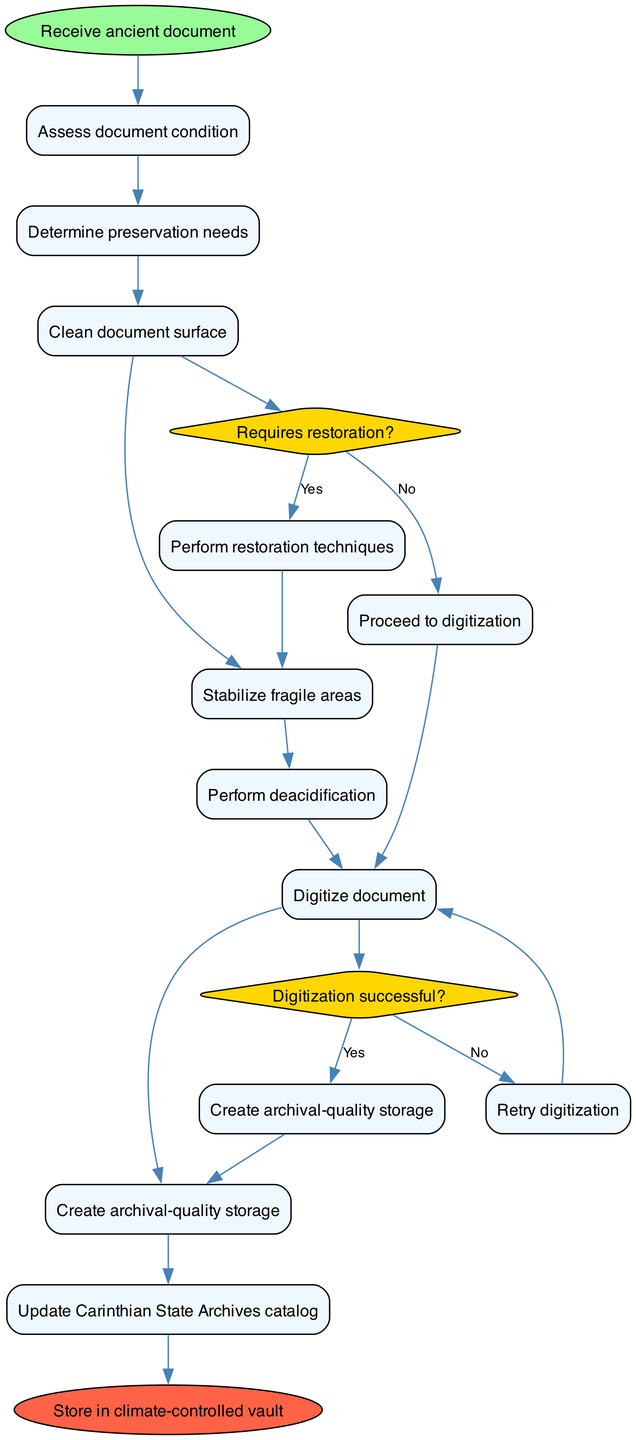What is the starting point of the restoration process? The starting point of the restoration process is indicated by the "Receive ancient document" node. This is where the entire process begins, as shown in the diagram.
Answer: Receive ancient document How many activities are outlined in the restoration process? Counting the nodes labeled as activities in the diagram, we can identify eight distinct activities listed sequentially.
Answer: 8 What is the decision question related to restoration? The decision question concerning restoration can be found in the "Requires restoration?" diamond node within the diagram. This question leads to further actions depending on the answer.
Answer: Requires restoration? What follows after "Assess document condition"? Analyzing the flow from the "Assess document condition" activity, the next activity shown in the diagram is "Determine preservation needs," which follows in sequence.
Answer: Determine preservation needs What happens if the digitization is unsuccessful? According to the diagram's flow, if the answer to "Digitization successful?" is "No," the process returns to "Retry digitization," indicating that this action will be taken next.
Answer: Retry digitization Which activity is last before storage? The final activity prior to storage in the process flow is "Update Carinthian State Archives catalog," as indicated by the sequential flow leading to the end node.
Answer: Update Carinthian State Archives catalog How many decision points are present in the diagram? The diagram contains two distinct decision points represented by diamond-shaped nodes, each of which guides the flow based on yes/no answers.
Answer: 2 After "Perform restoration techniques", which activity follows? After performing restoration techniques, the next activity shown in the diagram is "Clean document surface." This follows logically in the process flow.
Answer: Clean document surface What is the end node of the restoration process? The final destination of the diagram is represented by the end node labeled "Store in climate-controlled vault," indicating where the process concludes.
Answer: Store in climate-controlled vault 